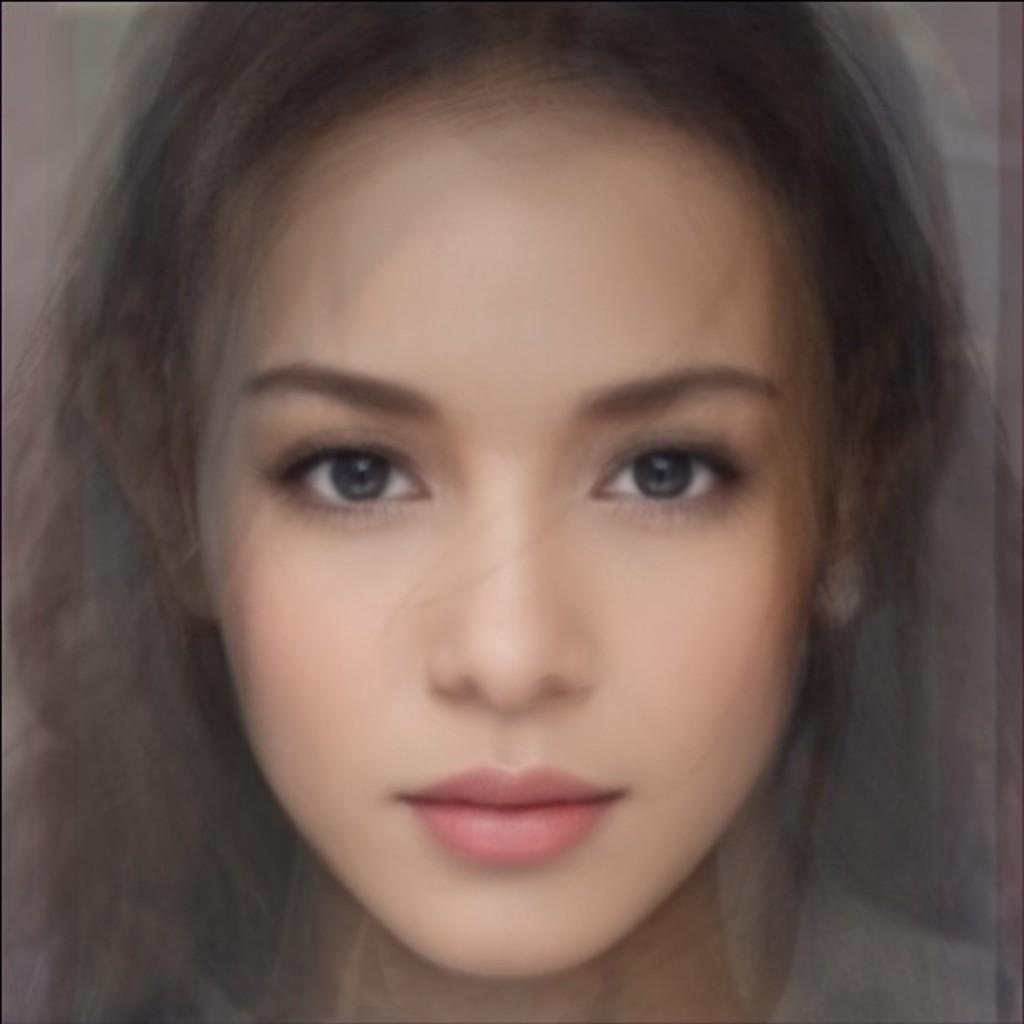What is the main subject of the image? There is a girl's face in the image. Can you describe the girl's facial features? Unfortunately, the image only shows the girl's face, so it's not possible to describe her facial features in detail. What type of end is connected to the wire in the image? There is no wire or end present in the image; it only shows a girl's face. 